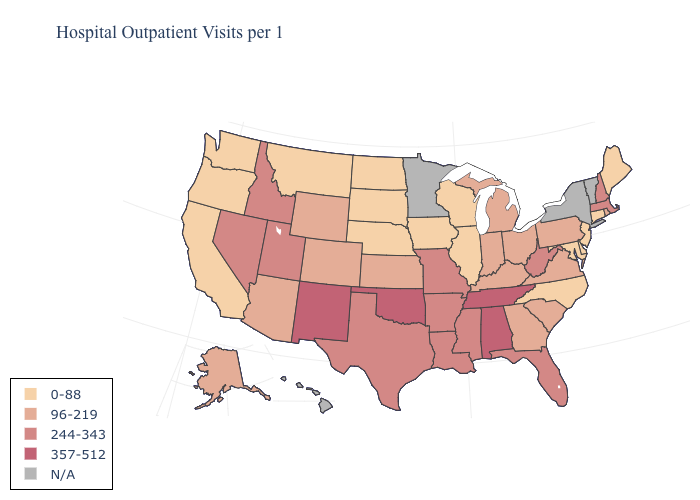Which states have the lowest value in the USA?
Short answer required. California, Connecticut, Delaware, Illinois, Iowa, Maine, Maryland, Montana, Nebraska, New Jersey, North Carolina, North Dakota, Oregon, South Dakota, Washington, Wisconsin. Which states hav the highest value in the MidWest?
Concise answer only. Missouri. What is the value of Oregon?
Answer briefly. 0-88. What is the highest value in states that border Mississippi?
Quick response, please. 357-512. Name the states that have a value in the range 244-343?
Answer briefly. Arkansas, Florida, Idaho, Louisiana, Massachusetts, Mississippi, Missouri, Nevada, New Hampshire, Texas, Utah, West Virginia. Among the states that border Michigan , does Indiana have the highest value?
Answer briefly. Yes. What is the value of Arkansas?
Keep it brief. 244-343. Among the states that border Colorado , which have the highest value?
Keep it brief. New Mexico, Oklahoma. Does North Carolina have the lowest value in the South?
Short answer required. Yes. Among the states that border Nevada , does Idaho have the lowest value?
Answer briefly. No. What is the lowest value in the USA?
Write a very short answer. 0-88. Among the states that border Kentucky , does Ohio have the highest value?
Quick response, please. No. Name the states that have a value in the range 244-343?
Short answer required. Arkansas, Florida, Idaho, Louisiana, Massachusetts, Mississippi, Missouri, Nevada, New Hampshire, Texas, Utah, West Virginia. What is the value of Florida?
Short answer required. 244-343. What is the value of Texas?
Give a very brief answer. 244-343. 